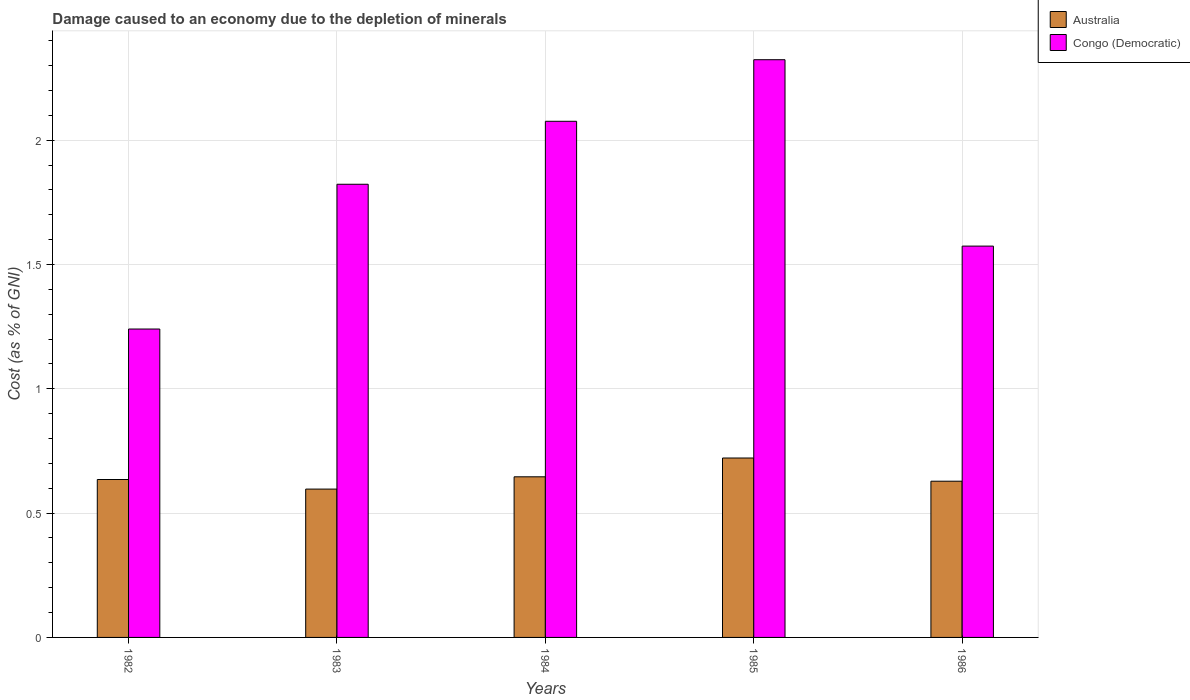How many different coloured bars are there?
Provide a succinct answer. 2. How many groups of bars are there?
Offer a terse response. 5. Are the number of bars per tick equal to the number of legend labels?
Make the answer very short. Yes. How many bars are there on the 4th tick from the left?
Provide a short and direct response. 2. In how many cases, is the number of bars for a given year not equal to the number of legend labels?
Offer a very short reply. 0. What is the cost of damage caused due to the depletion of minerals in Australia in 1983?
Keep it short and to the point. 0.6. Across all years, what is the maximum cost of damage caused due to the depletion of minerals in Australia?
Offer a terse response. 0.72. Across all years, what is the minimum cost of damage caused due to the depletion of minerals in Australia?
Your response must be concise. 0.6. In which year was the cost of damage caused due to the depletion of minerals in Congo (Democratic) maximum?
Give a very brief answer. 1985. In which year was the cost of damage caused due to the depletion of minerals in Congo (Democratic) minimum?
Make the answer very short. 1982. What is the total cost of damage caused due to the depletion of minerals in Congo (Democratic) in the graph?
Your answer should be very brief. 9.04. What is the difference between the cost of damage caused due to the depletion of minerals in Australia in 1982 and that in 1984?
Offer a terse response. -0.01. What is the difference between the cost of damage caused due to the depletion of minerals in Congo (Democratic) in 1982 and the cost of damage caused due to the depletion of minerals in Australia in 1985?
Your answer should be very brief. 0.52. What is the average cost of damage caused due to the depletion of minerals in Congo (Democratic) per year?
Provide a succinct answer. 1.81. In the year 1986, what is the difference between the cost of damage caused due to the depletion of minerals in Congo (Democratic) and cost of damage caused due to the depletion of minerals in Australia?
Provide a short and direct response. 0.95. What is the ratio of the cost of damage caused due to the depletion of minerals in Congo (Democratic) in 1982 to that in 1986?
Give a very brief answer. 0.79. Is the difference between the cost of damage caused due to the depletion of minerals in Congo (Democratic) in 1982 and 1984 greater than the difference between the cost of damage caused due to the depletion of minerals in Australia in 1982 and 1984?
Keep it short and to the point. No. What is the difference between the highest and the second highest cost of damage caused due to the depletion of minerals in Congo (Democratic)?
Your response must be concise. 0.25. What is the difference between the highest and the lowest cost of damage caused due to the depletion of minerals in Congo (Democratic)?
Provide a succinct answer. 1.08. In how many years, is the cost of damage caused due to the depletion of minerals in Australia greater than the average cost of damage caused due to the depletion of minerals in Australia taken over all years?
Offer a very short reply. 2. What does the 2nd bar from the left in 1983 represents?
Ensure brevity in your answer.  Congo (Democratic). What does the 1st bar from the right in 1985 represents?
Your response must be concise. Congo (Democratic). How many years are there in the graph?
Make the answer very short. 5. Are the values on the major ticks of Y-axis written in scientific E-notation?
Offer a terse response. No. Does the graph contain any zero values?
Keep it short and to the point. No. What is the title of the graph?
Provide a succinct answer. Damage caused to an economy due to the depletion of minerals. What is the label or title of the X-axis?
Your response must be concise. Years. What is the label or title of the Y-axis?
Your response must be concise. Cost (as % of GNI). What is the Cost (as % of GNI) in Australia in 1982?
Provide a short and direct response. 0.64. What is the Cost (as % of GNI) in Congo (Democratic) in 1982?
Make the answer very short. 1.24. What is the Cost (as % of GNI) of Australia in 1983?
Provide a short and direct response. 0.6. What is the Cost (as % of GNI) in Congo (Democratic) in 1983?
Provide a short and direct response. 1.82. What is the Cost (as % of GNI) of Australia in 1984?
Your answer should be very brief. 0.65. What is the Cost (as % of GNI) of Congo (Democratic) in 1984?
Offer a terse response. 2.08. What is the Cost (as % of GNI) of Australia in 1985?
Make the answer very short. 0.72. What is the Cost (as % of GNI) in Congo (Democratic) in 1985?
Keep it short and to the point. 2.32. What is the Cost (as % of GNI) in Australia in 1986?
Ensure brevity in your answer.  0.63. What is the Cost (as % of GNI) of Congo (Democratic) in 1986?
Offer a terse response. 1.57. Across all years, what is the maximum Cost (as % of GNI) of Australia?
Your response must be concise. 0.72. Across all years, what is the maximum Cost (as % of GNI) of Congo (Democratic)?
Your answer should be compact. 2.32. Across all years, what is the minimum Cost (as % of GNI) of Australia?
Your response must be concise. 0.6. Across all years, what is the minimum Cost (as % of GNI) of Congo (Democratic)?
Keep it short and to the point. 1.24. What is the total Cost (as % of GNI) of Australia in the graph?
Make the answer very short. 3.23. What is the total Cost (as % of GNI) in Congo (Democratic) in the graph?
Keep it short and to the point. 9.04. What is the difference between the Cost (as % of GNI) in Australia in 1982 and that in 1983?
Your answer should be very brief. 0.04. What is the difference between the Cost (as % of GNI) in Congo (Democratic) in 1982 and that in 1983?
Offer a terse response. -0.58. What is the difference between the Cost (as % of GNI) of Australia in 1982 and that in 1984?
Your answer should be compact. -0.01. What is the difference between the Cost (as % of GNI) of Congo (Democratic) in 1982 and that in 1984?
Give a very brief answer. -0.84. What is the difference between the Cost (as % of GNI) of Australia in 1982 and that in 1985?
Offer a very short reply. -0.09. What is the difference between the Cost (as % of GNI) of Congo (Democratic) in 1982 and that in 1985?
Offer a very short reply. -1.08. What is the difference between the Cost (as % of GNI) in Australia in 1982 and that in 1986?
Your answer should be very brief. 0.01. What is the difference between the Cost (as % of GNI) of Congo (Democratic) in 1982 and that in 1986?
Make the answer very short. -0.33. What is the difference between the Cost (as % of GNI) of Australia in 1983 and that in 1984?
Your answer should be compact. -0.05. What is the difference between the Cost (as % of GNI) of Congo (Democratic) in 1983 and that in 1984?
Offer a very short reply. -0.25. What is the difference between the Cost (as % of GNI) in Australia in 1983 and that in 1985?
Provide a succinct answer. -0.12. What is the difference between the Cost (as % of GNI) in Congo (Democratic) in 1983 and that in 1985?
Make the answer very short. -0.5. What is the difference between the Cost (as % of GNI) of Australia in 1983 and that in 1986?
Your answer should be very brief. -0.03. What is the difference between the Cost (as % of GNI) in Congo (Democratic) in 1983 and that in 1986?
Give a very brief answer. 0.25. What is the difference between the Cost (as % of GNI) of Australia in 1984 and that in 1985?
Your answer should be compact. -0.08. What is the difference between the Cost (as % of GNI) in Congo (Democratic) in 1984 and that in 1985?
Your response must be concise. -0.25. What is the difference between the Cost (as % of GNI) of Australia in 1984 and that in 1986?
Ensure brevity in your answer.  0.02. What is the difference between the Cost (as % of GNI) in Congo (Democratic) in 1984 and that in 1986?
Give a very brief answer. 0.5. What is the difference between the Cost (as % of GNI) in Australia in 1985 and that in 1986?
Provide a succinct answer. 0.09. What is the difference between the Cost (as % of GNI) in Congo (Democratic) in 1985 and that in 1986?
Your answer should be compact. 0.75. What is the difference between the Cost (as % of GNI) of Australia in 1982 and the Cost (as % of GNI) of Congo (Democratic) in 1983?
Provide a short and direct response. -1.19. What is the difference between the Cost (as % of GNI) of Australia in 1982 and the Cost (as % of GNI) of Congo (Democratic) in 1984?
Offer a very short reply. -1.44. What is the difference between the Cost (as % of GNI) in Australia in 1982 and the Cost (as % of GNI) in Congo (Democratic) in 1985?
Your answer should be compact. -1.69. What is the difference between the Cost (as % of GNI) in Australia in 1982 and the Cost (as % of GNI) in Congo (Democratic) in 1986?
Offer a terse response. -0.94. What is the difference between the Cost (as % of GNI) in Australia in 1983 and the Cost (as % of GNI) in Congo (Democratic) in 1984?
Offer a very short reply. -1.48. What is the difference between the Cost (as % of GNI) in Australia in 1983 and the Cost (as % of GNI) in Congo (Democratic) in 1985?
Provide a succinct answer. -1.73. What is the difference between the Cost (as % of GNI) in Australia in 1983 and the Cost (as % of GNI) in Congo (Democratic) in 1986?
Your answer should be very brief. -0.98. What is the difference between the Cost (as % of GNI) of Australia in 1984 and the Cost (as % of GNI) of Congo (Democratic) in 1985?
Your response must be concise. -1.68. What is the difference between the Cost (as % of GNI) in Australia in 1984 and the Cost (as % of GNI) in Congo (Democratic) in 1986?
Offer a terse response. -0.93. What is the difference between the Cost (as % of GNI) in Australia in 1985 and the Cost (as % of GNI) in Congo (Democratic) in 1986?
Keep it short and to the point. -0.85. What is the average Cost (as % of GNI) in Australia per year?
Offer a terse response. 0.65. What is the average Cost (as % of GNI) of Congo (Democratic) per year?
Offer a terse response. 1.81. In the year 1982, what is the difference between the Cost (as % of GNI) in Australia and Cost (as % of GNI) in Congo (Democratic)?
Provide a short and direct response. -0.61. In the year 1983, what is the difference between the Cost (as % of GNI) of Australia and Cost (as % of GNI) of Congo (Democratic)?
Your answer should be very brief. -1.23. In the year 1984, what is the difference between the Cost (as % of GNI) in Australia and Cost (as % of GNI) in Congo (Democratic)?
Give a very brief answer. -1.43. In the year 1985, what is the difference between the Cost (as % of GNI) of Australia and Cost (as % of GNI) of Congo (Democratic)?
Your answer should be very brief. -1.6. In the year 1986, what is the difference between the Cost (as % of GNI) of Australia and Cost (as % of GNI) of Congo (Democratic)?
Provide a short and direct response. -0.95. What is the ratio of the Cost (as % of GNI) of Australia in 1982 to that in 1983?
Offer a terse response. 1.06. What is the ratio of the Cost (as % of GNI) in Congo (Democratic) in 1982 to that in 1983?
Make the answer very short. 0.68. What is the ratio of the Cost (as % of GNI) of Australia in 1982 to that in 1984?
Make the answer very short. 0.98. What is the ratio of the Cost (as % of GNI) in Congo (Democratic) in 1982 to that in 1984?
Give a very brief answer. 0.6. What is the ratio of the Cost (as % of GNI) of Australia in 1982 to that in 1985?
Make the answer very short. 0.88. What is the ratio of the Cost (as % of GNI) of Congo (Democratic) in 1982 to that in 1985?
Offer a very short reply. 0.53. What is the ratio of the Cost (as % of GNI) of Australia in 1982 to that in 1986?
Keep it short and to the point. 1.01. What is the ratio of the Cost (as % of GNI) of Congo (Democratic) in 1982 to that in 1986?
Give a very brief answer. 0.79. What is the ratio of the Cost (as % of GNI) of Australia in 1983 to that in 1984?
Give a very brief answer. 0.92. What is the ratio of the Cost (as % of GNI) of Congo (Democratic) in 1983 to that in 1984?
Ensure brevity in your answer.  0.88. What is the ratio of the Cost (as % of GNI) in Australia in 1983 to that in 1985?
Keep it short and to the point. 0.83. What is the ratio of the Cost (as % of GNI) in Congo (Democratic) in 1983 to that in 1985?
Provide a short and direct response. 0.78. What is the ratio of the Cost (as % of GNI) in Australia in 1983 to that in 1986?
Keep it short and to the point. 0.95. What is the ratio of the Cost (as % of GNI) of Congo (Democratic) in 1983 to that in 1986?
Your answer should be very brief. 1.16. What is the ratio of the Cost (as % of GNI) of Australia in 1984 to that in 1985?
Provide a succinct answer. 0.9. What is the ratio of the Cost (as % of GNI) in Congo (Democratic) in 1984 to that in 1985?
Offer a terse response. 0.89. What is the ratio of the Cost (as % of GNI) of Australia in 1984 to that in 1986?
Keep it short and to the point. 1.03. What is the ratio of the Cost (as % of GNI) in Congo (Democratic) in 1984 to that in 1986?
Give a very brief answer. 1.32. What is the ratio of the Cost (as % of GNI) in Australia in 1985 to that in 1986?
Provide a succinct answer. 1.15. What is the ratio of the Cost (as % of GNI) of Congo (Democratic) in 1985 to that in 1986?
Give a very brief answer. 1.48. What is the difference between the highest and the second highest Cost (as % of GNI) of Australia?
Ensure brevity in your answer.  0.08. What is the difference between the highest and the second highest Cost (as % of GNI) in Congo (Democratic)?
Your answer should be very brief. 0.25. What is the difference between the highest and the lowest Cost (as % of GNI) in Australia?
Your answer should be compact. 0.12. 